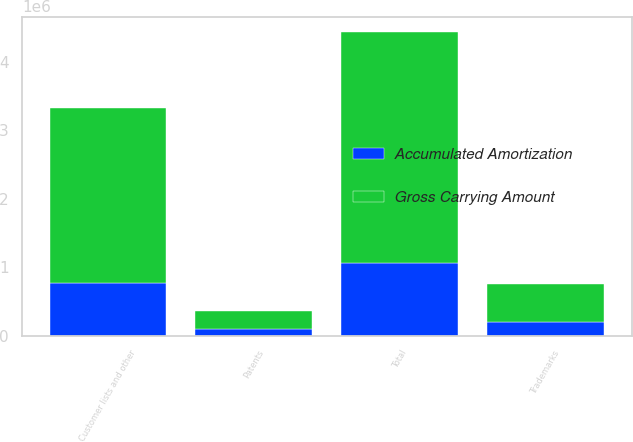Convert chart. <chart><loc_0><loc_0><loc_500><loc_500><stacked_bar_chart><ecel><fcel>Patents<fcel>Trademarks<fcel>Customer lists and other<fcel>Total<nl><fcel>Gross Carrying Amount<fcel>254049<fcel>553691<fcel>2.56698e+06<fcel>3.37472e+06<nl><fcel>Accumulated Amortization<fcel>100860<fcel>200413<fcel>765966<fcel>1.06724e+06<nl></chart> 